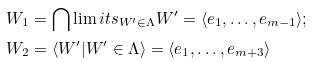Convert formula to latex. <formula><loc_0><loc_0><loc_500><loc_500>W _ { 1 } & = \bigcap \lim i t s _ { W ^ { \prime } \in \Lambda } W ^ { \prime } = \langle e _ { 1 } , \dots , e _ { m - 1 } \rangle ; \\ W _ { 2 } & = \langle W ^ { \prime } | W ^ { \prime } \in \Lambda \rangle = \langle e _ { 1 } , \dots , e _ { m + 3 } \rangle</formula> 